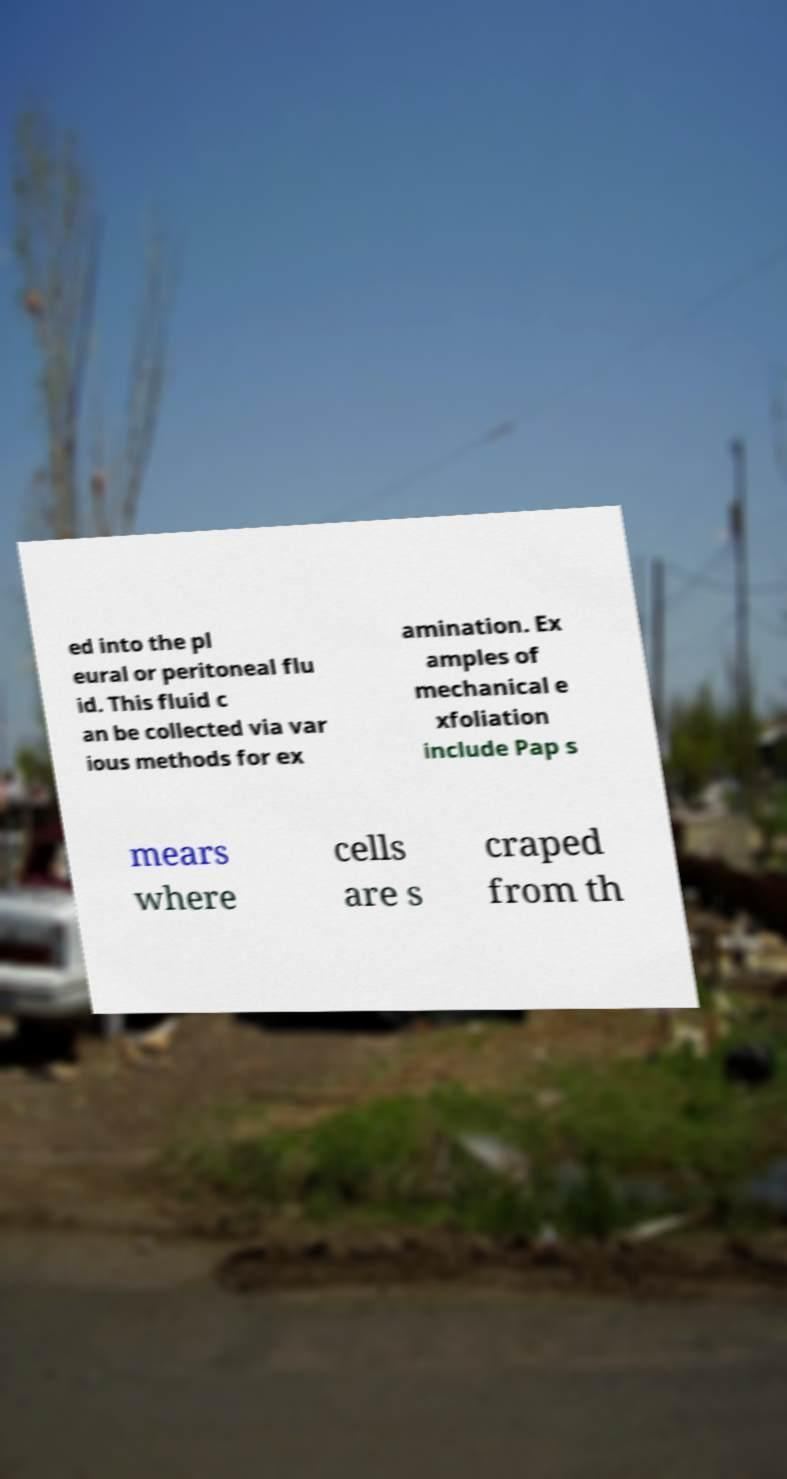There's text embedded in this image that I need extracted. Can you transcribe it verbatim? ed into the pl eural or peritoneal flu id. This fluid c an be collected via var ious methods for ex amination. Ex amples of mechanical e xfoliation include Pap s mears where cells are s craped from th 